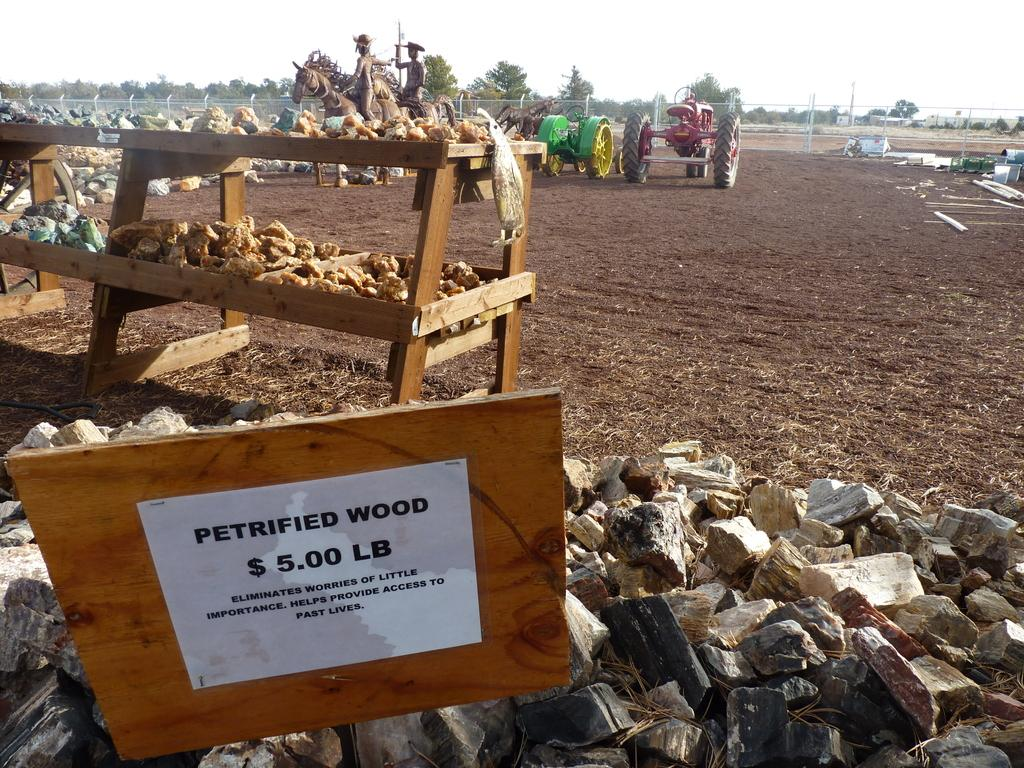<image>
Give a short and clear explanation of the subsequent image. A pile of petrified wood for $5.00 lb. outside in a field. 